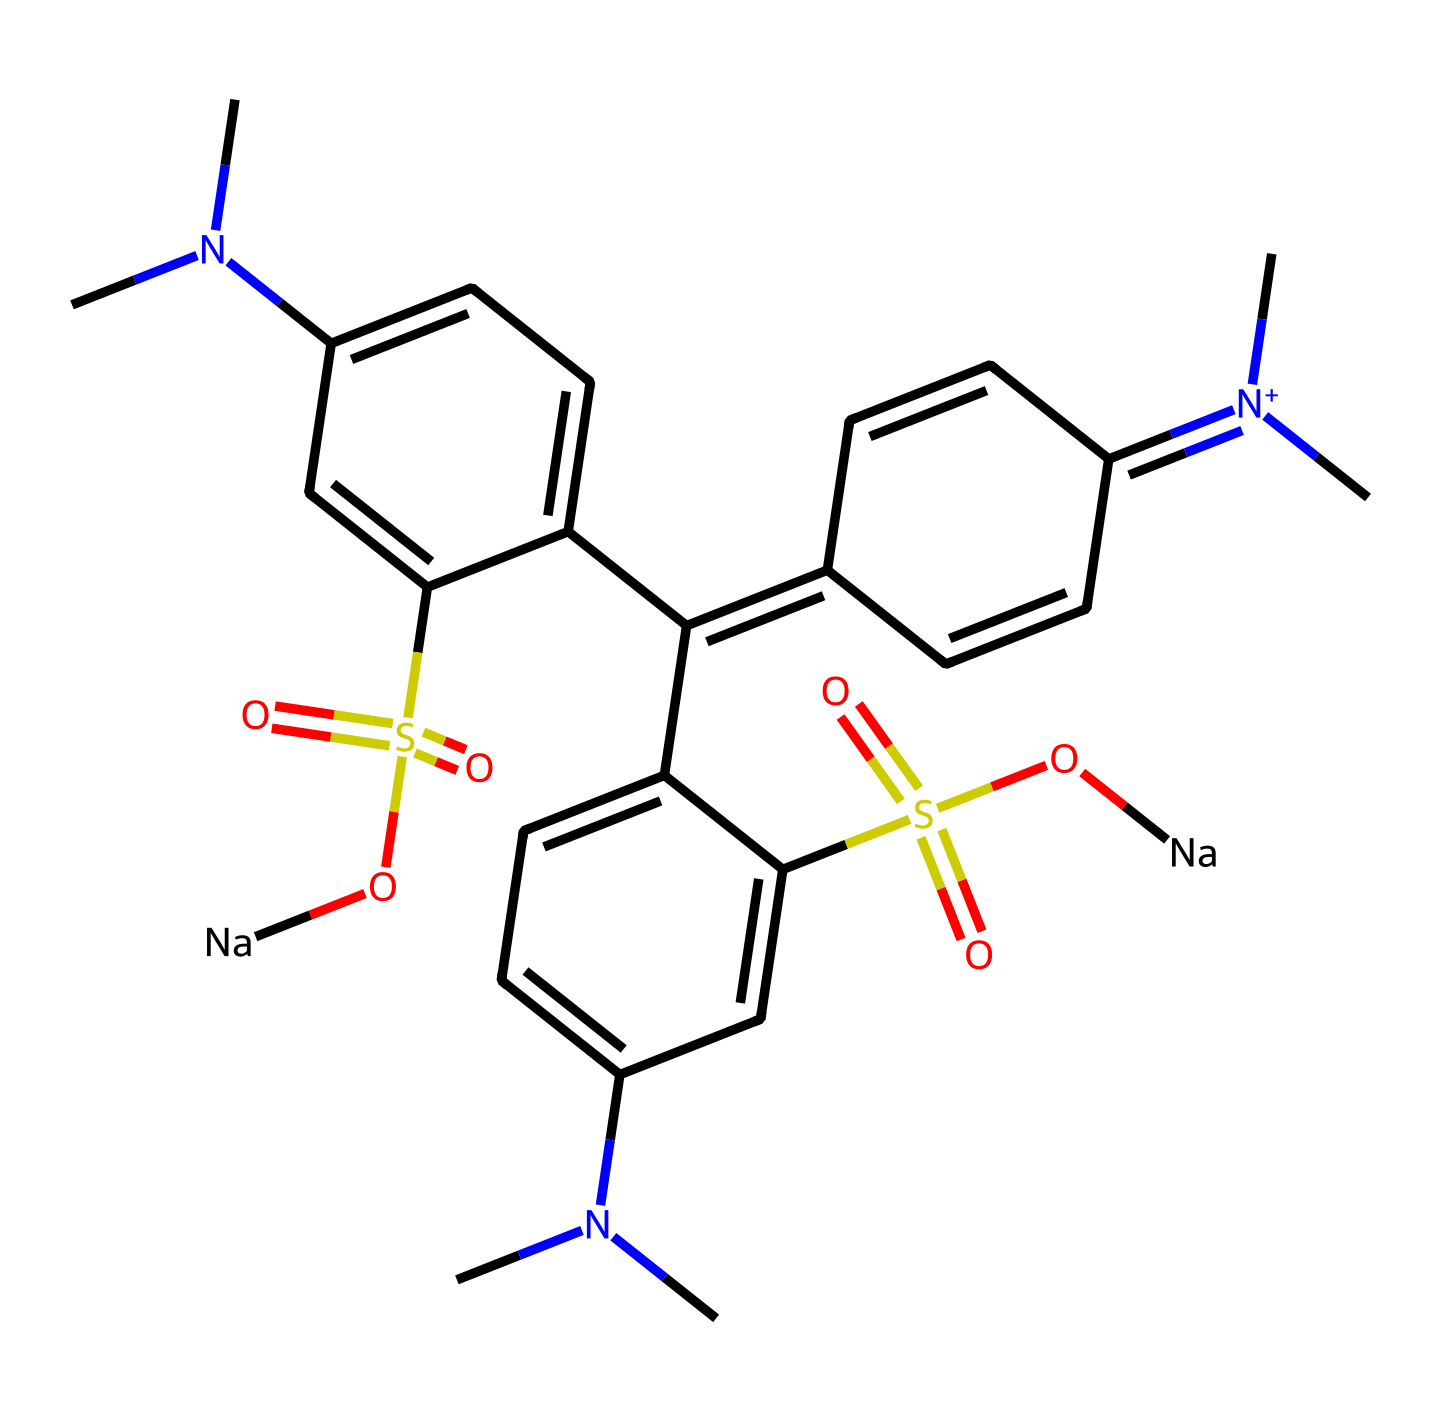What is the molecular formula of this dye? To determine the molecular formula, we count each type of atom present in the structure. The key elements to identify are carbon (C), hydrogen (H), nitrogen (N), oxygen (O), and sulfur (S). After analyzing the SMILES representation, the counts are: carbon=18, hydrogen=22, nitrogen=2, oxygen=4, sulfur=2. Therefore, the molecular formula is C18H22N2O4S2.
Answer: C18H22N2O4S2 How many nitrogen atoms are in this chemical? By examining the SMILES structure, we can identify each nitrogen atom present. The total counts from the SMILES reveal there are 2 nitrogen atoms in the molecule.
Answer: 2 What type of dye is represented by this chemical structure? The chemical structure indicates a synthetic dye, specifically an azo dye due to the presence of nitrogen with a positive charge linked to an aromatic system and multiple sulfonic acid groups, typical for water-soluble dyes.
Answer: synthetic dye What is the role of the sulfonic acid groups in this dye? Sulfonic acid groups are present in the structure, and their role is to enhance the dye's solubility in water, making it suitable for food coloring applications. The presence of these groups contributes to the overall polarity of the molecule.
Answer: enhance solubility How many benzene rings are in this chemical structure? By inspecting the structure, we identify two distinct aromatic rings (benzene rings) within the molecule. The rings are formed by alternating double bonds and satisfy the criteria for aromaticity.
Answer: 2 What impact does the methyl group have on the properties of this dye? The methyl groups, indicated in the SMILES, influence the solubility and stability of the dye. Their presence contributes to hydrophobic interactions, affecting the overall hydrophobicity and, consequently, the dye's behavior in aqueous solutions.
Answer: affect solubility What is the charge of the nitrogen atom in the chemical? The SMILES notation includes [N+], indicating that the nitrogen atom carries a positive charge. This suggests that it plays a role in ionic interactions within the dye and with other molecules.
Answer: positive charge 